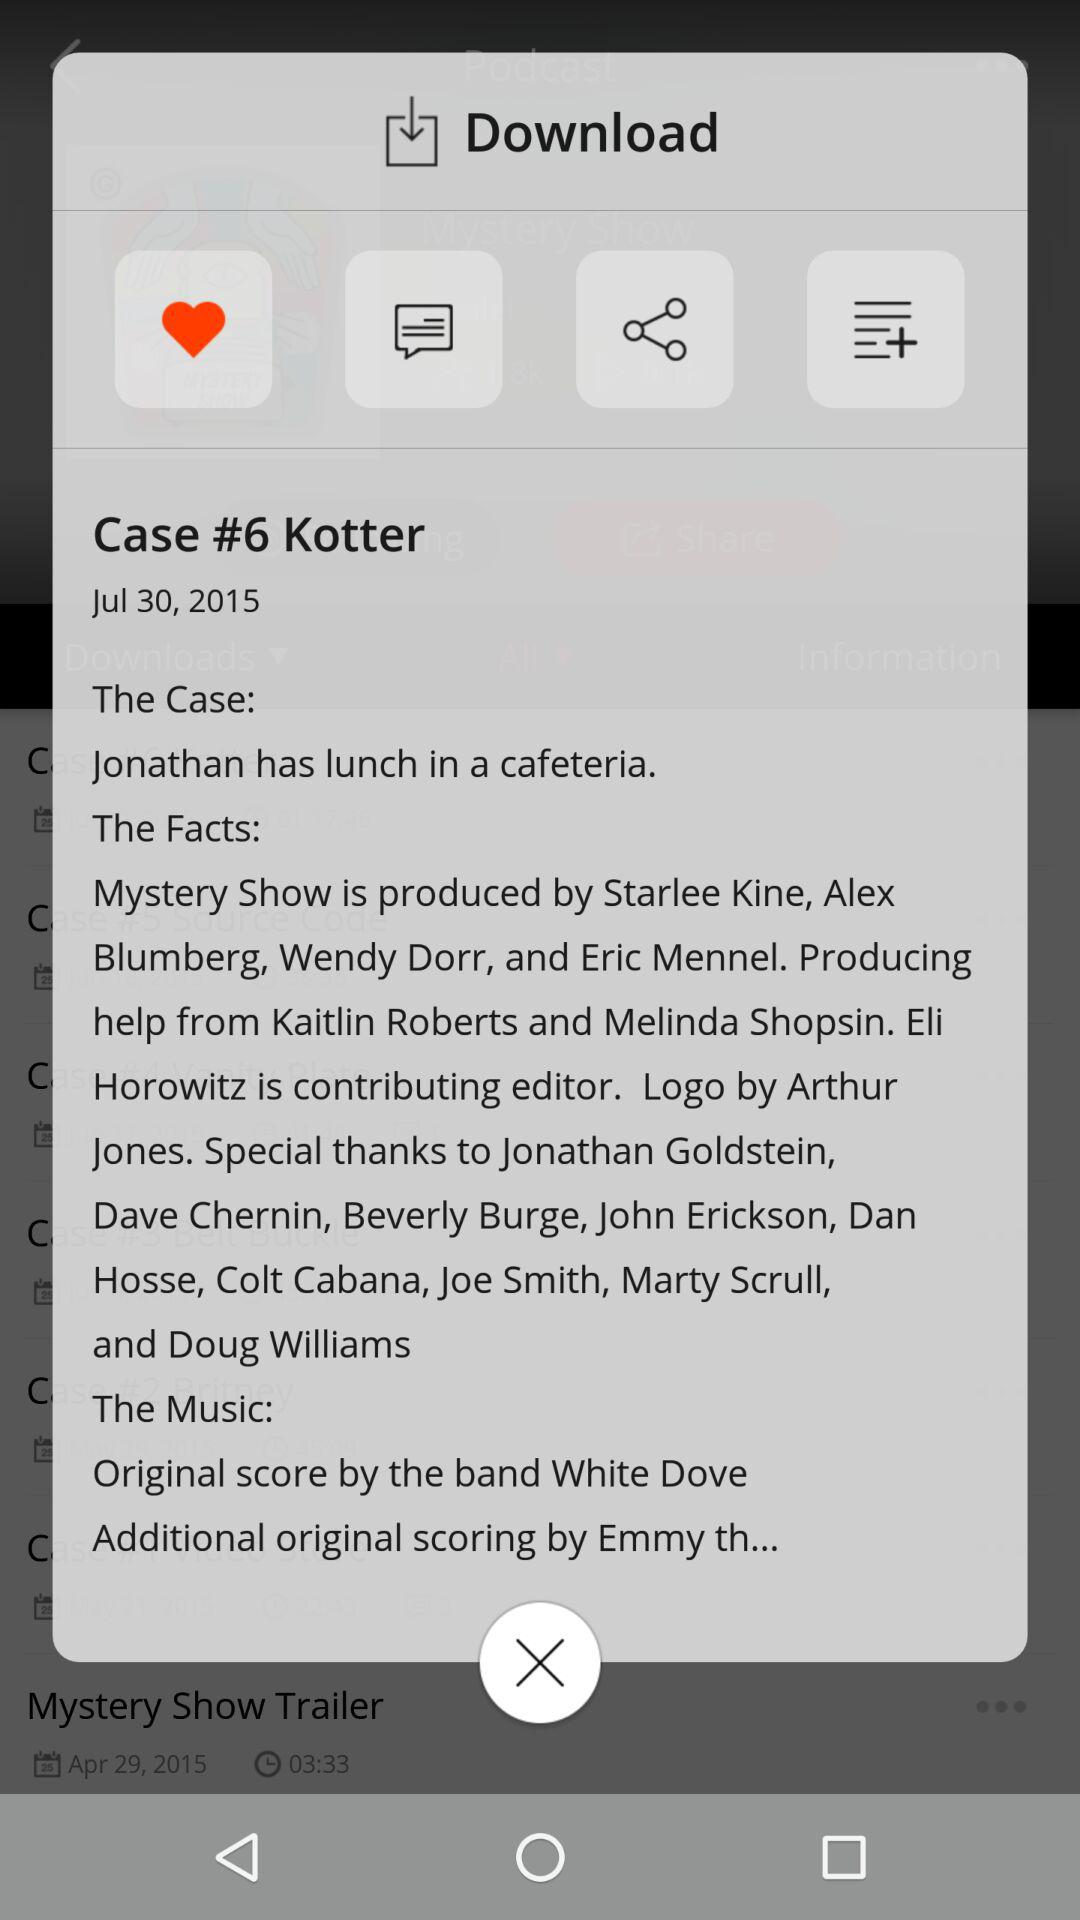What is the date of "Case #6 Kotter"? The date is July 30, 2015. 